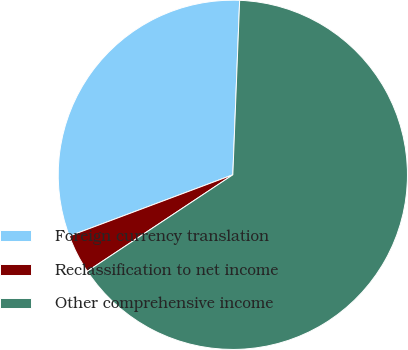<chart> <loc_0><loc_0><loc_500><loc_500><pie_chart><fcel>Foreign currency translation<fcel>Reclassification to net income<fcel>Other comprehensive income<nl><fcel>31.33%<fcel>3.61%<fcel>65.06%<nl></chart> 